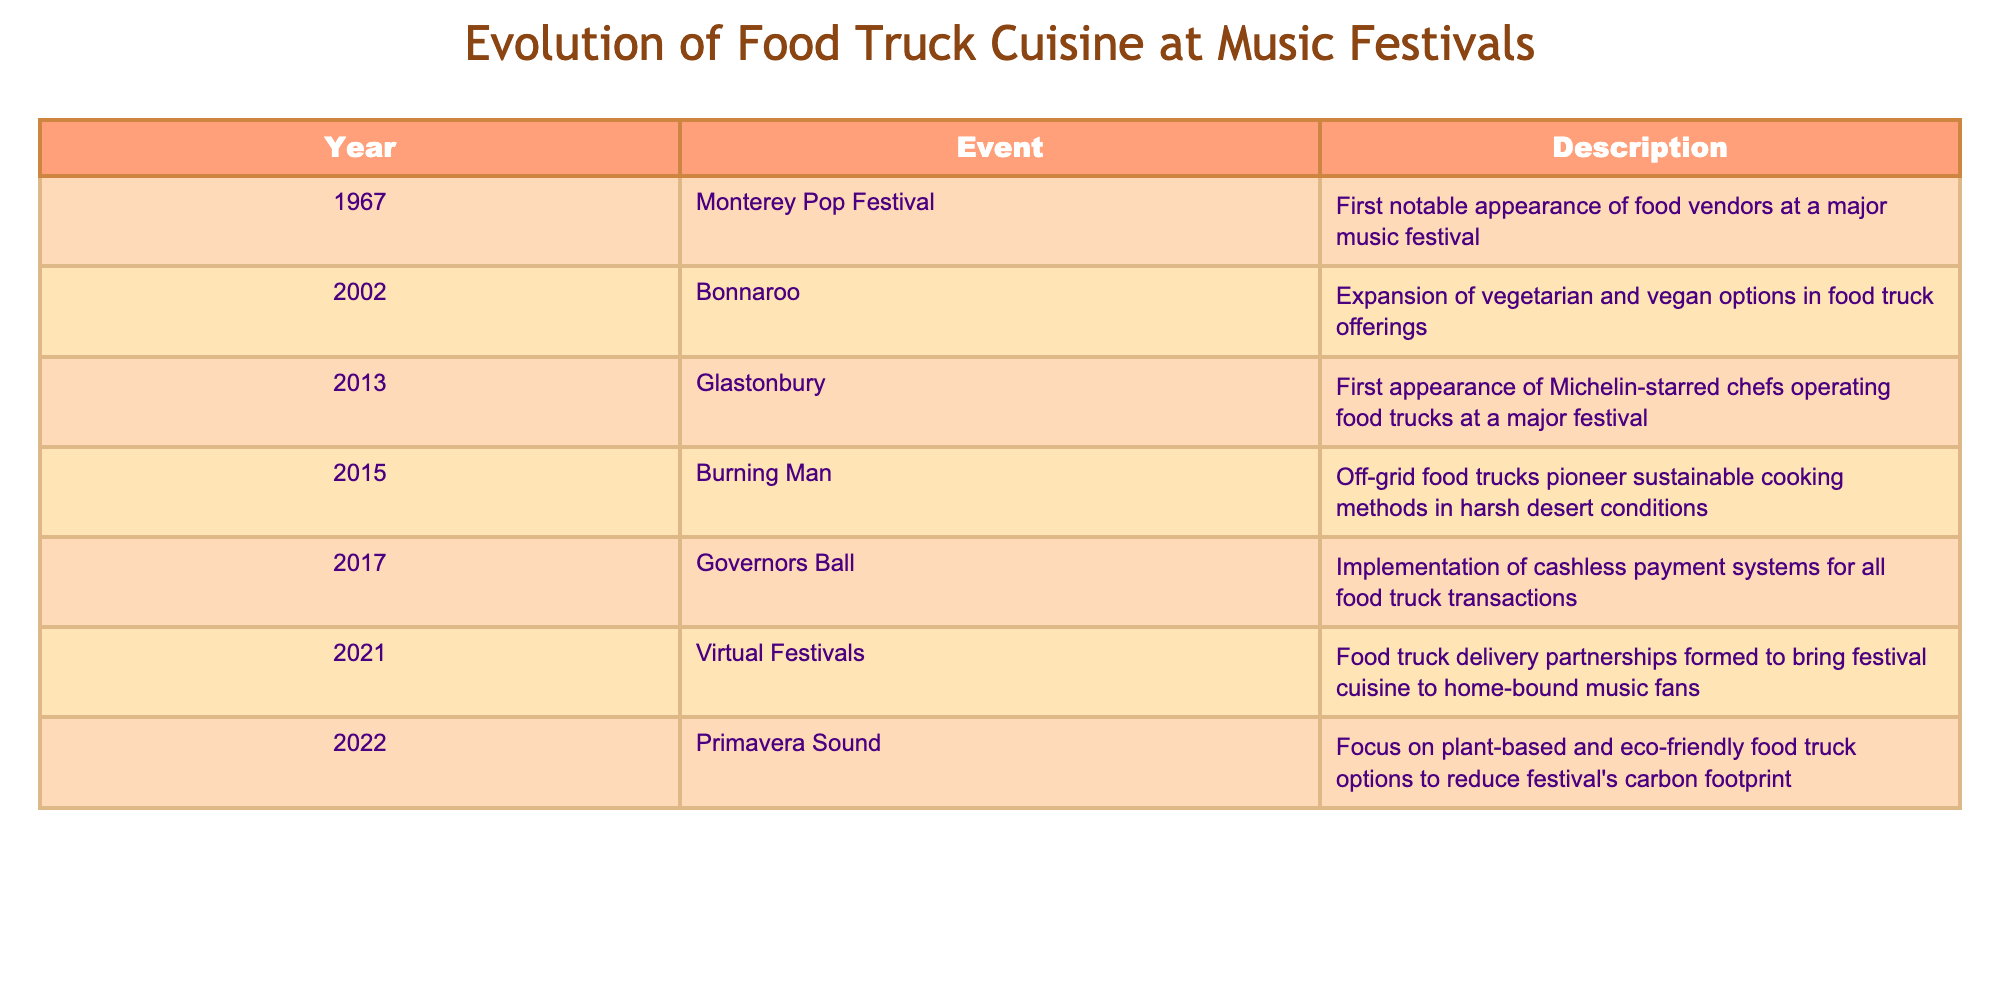What was the first notable appearance of food vendors at a major music festival? According to the table, the first notable appearance of food vendors happened in 1967 at the Monterey Pop Festival. The event is listed as such in the table.
Answer: Monterey Pop Festival Which event marked the implementation of cashless payment systems for all food truck transactions? The table shows that the implementation of cashless payment systems for all food truck transactions occurred in 2017 at the Governors Ball. This information can be found directly in the table under that year.
Answer: Governors Ball How many years passed between the first appearance of Michelin-starred chefs operating food trucks and the event that focused on plant-based and eco-friendly options? The first appearance of Michelin-starred chefs in food trucks was in 2013 and the focus on plant-based options occurred in 2022. To find the number of years, subtract 2013 from 2022, giving us 9 years.
Answer: 9 years Did any food truck events take place in a virtual format? The table confirms that in 2021, virtual festivals were held, where food truck delivery partnerships were formed for home-bound music fans. This indicates that events did occur in a virtual format in that year.
Answer: Yes In what year was the focus on vegetarian and vegan options expanded in food truck offerings? The table states that this expansion took place in 2002 at the Bonnaroo festival. This fact is clearly listed in the corresponding row of the table.
Answer: 2002 How many notable events mentioned in the table occurred after 2015? The events that took place after 2015 are: 2017 (Governors Ball), 2021 (Virtual Festivals), and 2022 (Primavera Sound)—a total of three events. Thus, summing these gives us a count of 3 notable events after 2015.
Answer: 3 events What was the significant contribution of food trucks at Burning Man in 2015? In 2015, Burning Man featured food trucks that pioneered sustainable cooking methods in harsh desert conditions. This specific information is found in the table under that event's description.
Answer: Sustainable cooking methods Which event was the last listed in the table? The last event mentioned in the table is Primavera Sound in 2022, which can be identified by the final row in the table.
Answer: Primavera Sound Were Michelin-starred chefs present at any festivals before 2013? Based on the table, Michelin-starred chefs operating food trucks first appeared in 2013 at Glastonbury, indicating no presence at prior festivals, thus making this a true statement.
Answer: No 